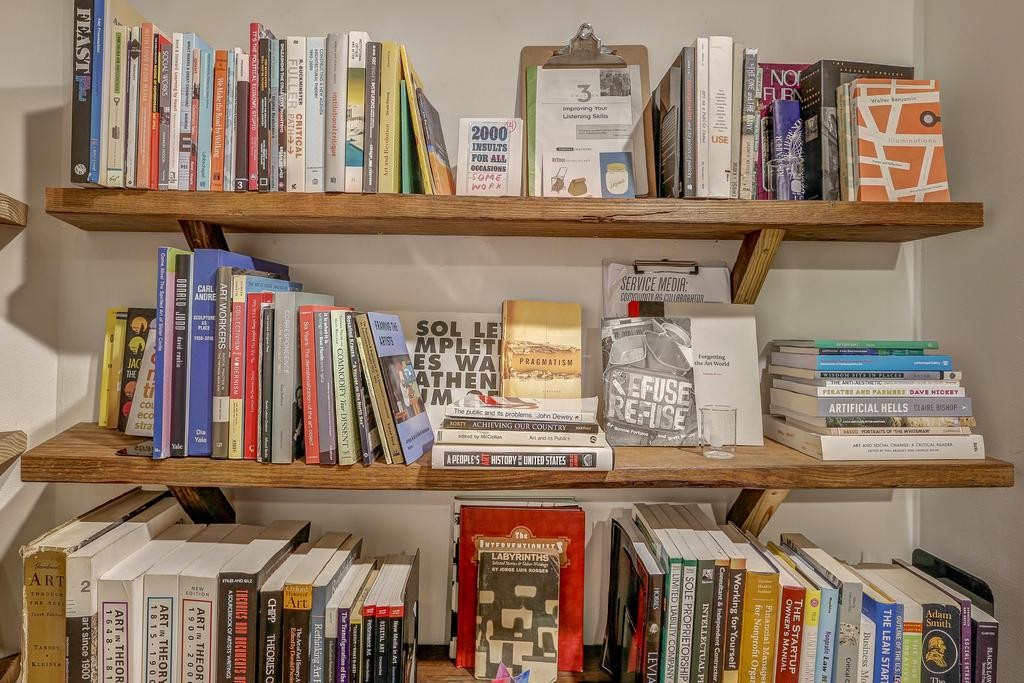<image>
Give a short and clear explanation of the subsequent image. Three shelves filled with books and one titled "2000 insults for all occasions" on the top shelf 